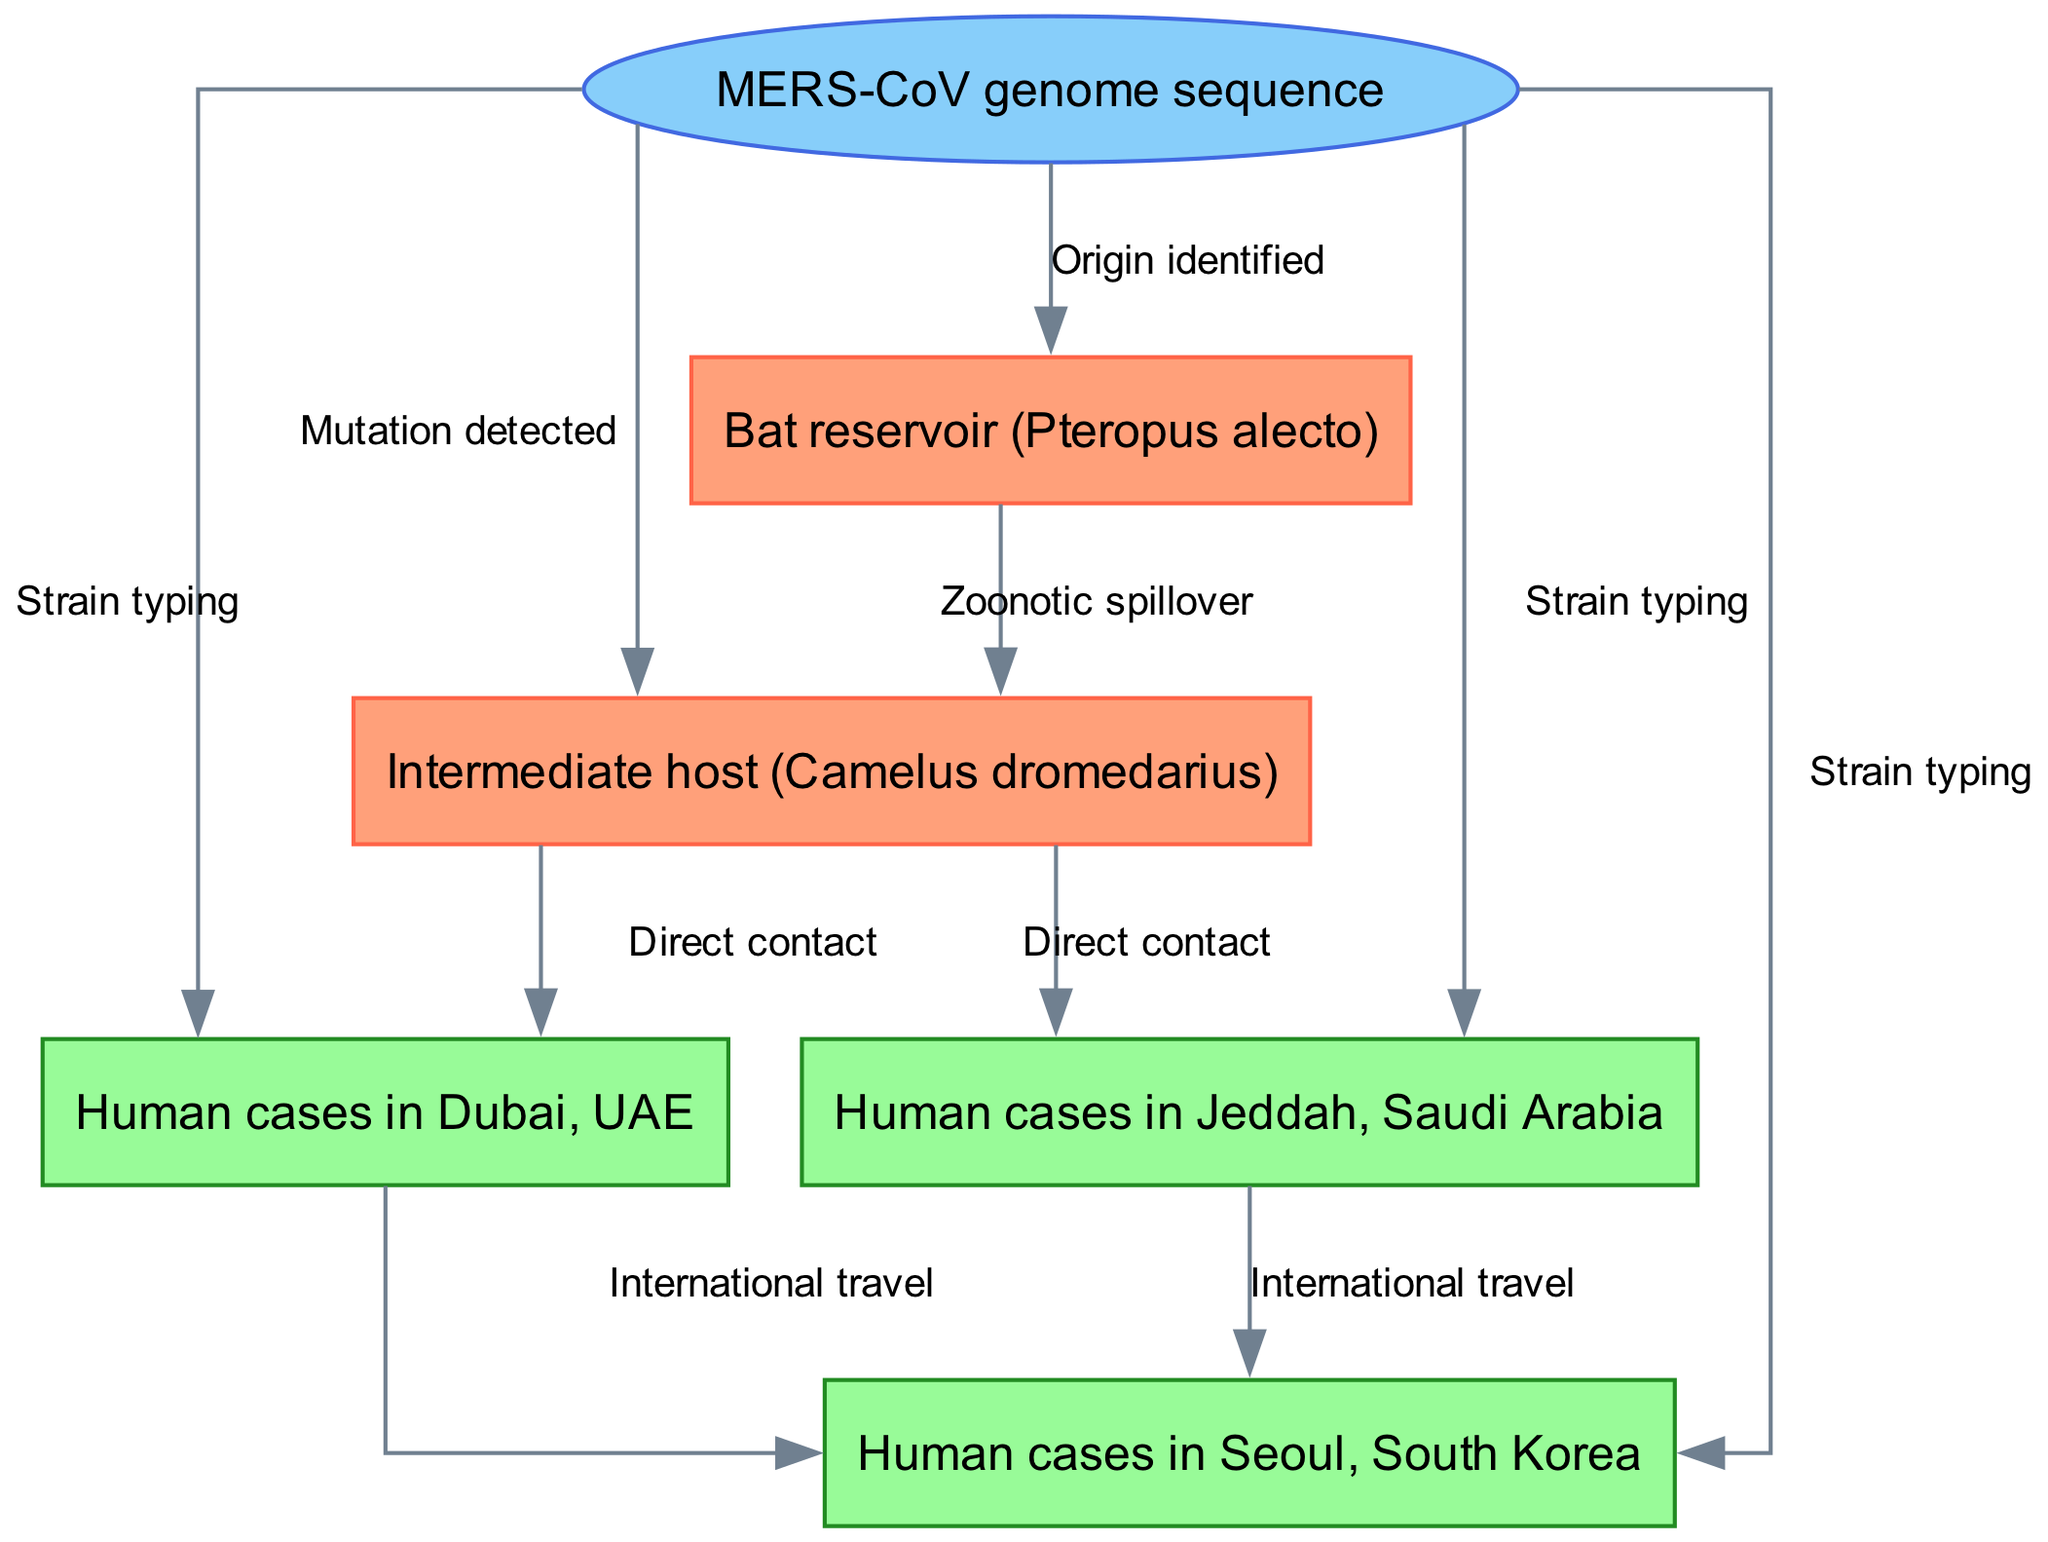What is the total number of nodes in the diagram? The diagram includes nodes for the bat reservoir, an intermediate host, three different human case locations, and a genetic sequence. Counting these gives a total of 6 nodes.
Answer: 6 Which human case location is associated with international travel from Dubai, UAE? The edge labeled "International travel" connects the Dubai node to the Seoul, South Korea node, indicating that this relationship exists.
Answer: Seoul, South Korea What type is the node representing the bat reservoir? The bat reservoir is categorized as an animal type based on the node's designation within the diagram.
Answer: animal How many edges connect the intermediate host to human cases? The intermediate host node connects to both the Jeddah and Dubai human case nodes through edges labeled "Direct contact", which totals 2 connections.
Answer: 2 What process is described by the edge from the bat reservoir to the intermediate host? The edge between the bat reservoir and the intermediate host describes the process of "Zoonotic spillover" which indicates transmission.
Answer: Zoonotic spillover Which node is the origin identified related to? The "MERS-CoV genome sequence" node connects back to the bat reservoir through an edge labeled "Origin identified", indicating the source of the genetic sequence is the bat reservoir.
Answer: Bat reservoir (Pteropus alecto) What is the relationship between human cases in Jeddah, Saudi Arabia and the MERS-CoV genome sequence? The relationship is indicated by the edge labeled "Strain typing", which connects these two nodes, showing a genetic analysis connection.
Answer: Strain typing Which geographic regions are represented in the human cases? The geographic regions represented include Jeddah in Saudi Arabia, Dubai in the UAE, and Seoul in South Korea, each shown as distinct nodes in the diagram.
Answer: Jeddah, Dubai, Seoul What label describes the connection from the MERS-CoV genome sequence to the intermediate host? The connection from the genetic sequence to the intermediate host is labeled "Mutation detected," indicating a genetic relationship.
Answer: Mutation detected 